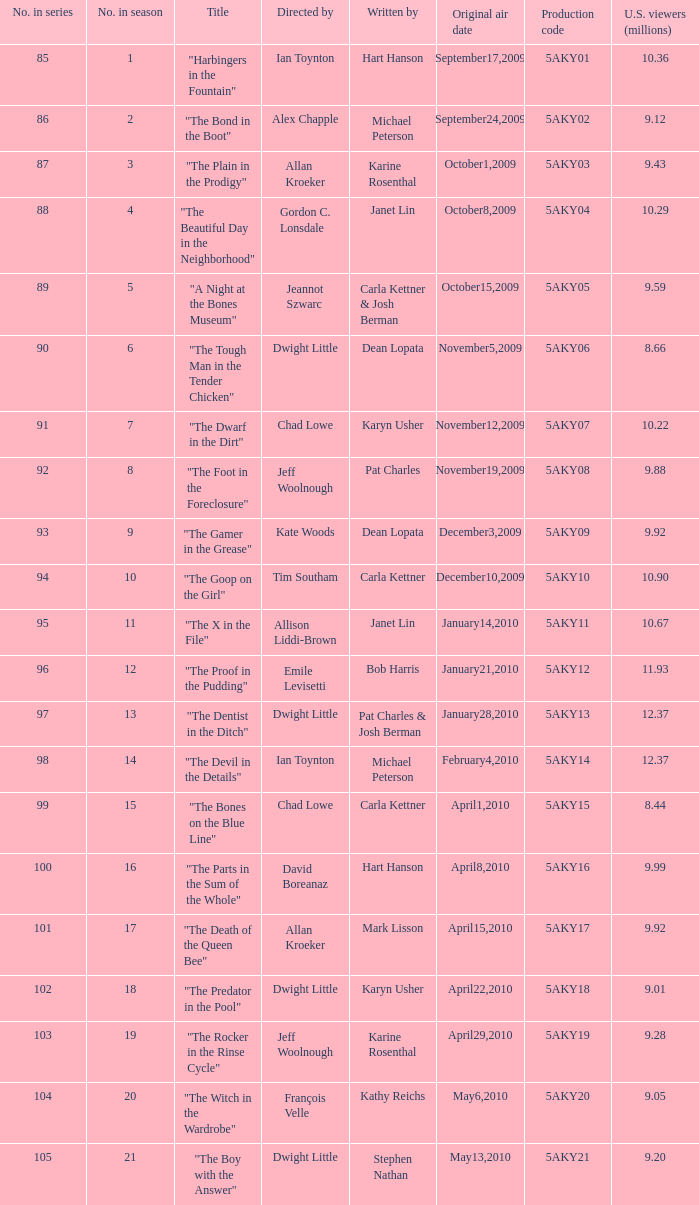What was the air date of the episode that has a production code of 5aky13? January28,2010. 